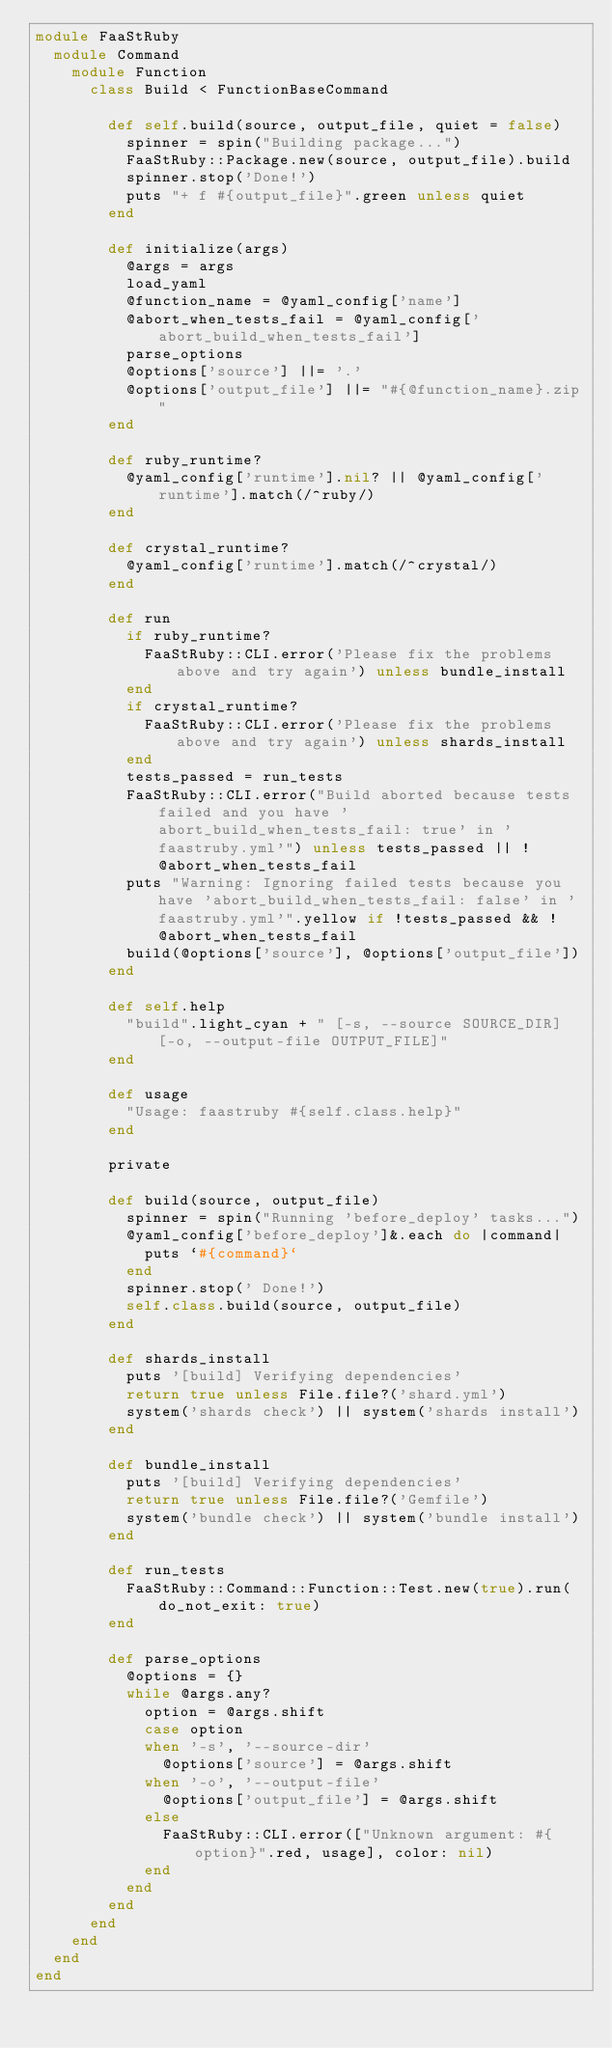Convert code to text. <code><loc_0><loc_0><loc_500><loc_500><_Ruby_>module FaaStRuby
  module Command
    module Function
      class Build < FunctionBaseCommand

        def self.build(source, output_file, quiet = false)
          spinner = spin("Building package...")
          FaaStRuby::Package.new(source, output_file).build
          spinner.stop('Done!')
          puts "+ f #{output_file}".green unless quiet
        end

        def initialize(args)
          @args = args
          load_yaml
          @function_name = @yaml_config['name']
          @abort_when_tests_fail = @yaml_config['abort_build_when_tests_fail']
          parse_options
          @options['source'] ||= '.'
          @options['output_file'] ||= "#{@function_name}.zip"
        end

        def ruby_runtime?
          @yaml_config['runtime'].nil? || @yaml_config['runtime'].match(/^ruby/)
        end

        def crystal_runtime?
          @yaml_config['runtime'].match(/^crystal/)
        end

        def run
          if ruby_runtime?
            FaaStRuby::CLI.error('Please fix the problems above and try again') unless bundle_install
          end
          if crystal_runtime?
            FaaStRuby::CLI.error('Please fix the problems above and try again') unless shards_install
          end
          tests_passed = run_tests
          FaaStRuby::CLI.error("Build aborted because tests failed and you have 'abort_build_when_tests_fail: true' in 'faastruby.yml'") unless tests_passed || !@abort_when_tests_fail
          puts "Warning: Ignoring failed tests because you have 'abort_build_when_tests_fail: false' in 'faastruby.yml'".yellow if !tests_passed && !@abort_when_tests_fail
          build(@options['source'], @options['output_file'])
        end

        def self.help
          "build".light_cyan + " [-s, --source SOURCE_DIR] [-o, --output-file OUTPUT_FILE]"
        end

        def usage
          "Usage: faastruby #{self.class.help}"
        end

        private

        def build(source, output_file)
          spinner = spin("Running 'before_deploy' tasks...")
          @yaml_config['before_deploy']&.each do |command|
            puts `#{command}`
          end
          spinner.stop(' Done!')
          self.class.build(source, output_file)
        end

        def shards_install
          puts '[build] Verifying dependencies'
          return true unless File.file?('shard.yml')
          system('shards check') || system('shards install')
        end

        def bundle_install
          puts '[build] Verifying dependencies'
          return true unless File.file?('Gemfile')
          system('bundle check') || system('bundle install')
        end

        def run_tests
          FaaStRuby::Command::Function::Test.new(true).run(do_not_exit: true)
        end

        def parse_options
          @options = {}
          while @args.any?
            option = @args.shift
            case option
            when '-s', '--source-dir'
              @options['source'] = @args.shift
            when '-o', '--output-file'
              @options['output_file'] = @args.shift
            else
              FaaStRuby::CLI.error(["Unknown argument: #{option}".red, usage], color: nil)
            end
          end
        end
      end
    end
  end
end
</code> 